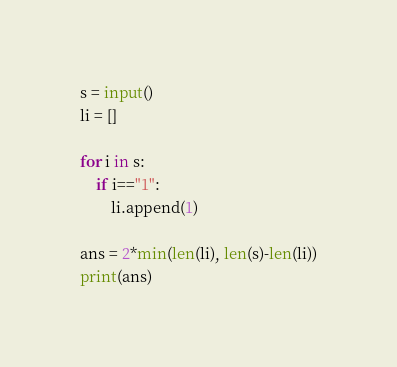Convert code to text. <code><loc_0><loc_0><loc_500><loc_500><_Python_>s = input()
li = []

for i in s:
    if i=="1":
        li.append(1)

ans = 2*min(len(li), len(s)-len(li))
print(ans)</code> 